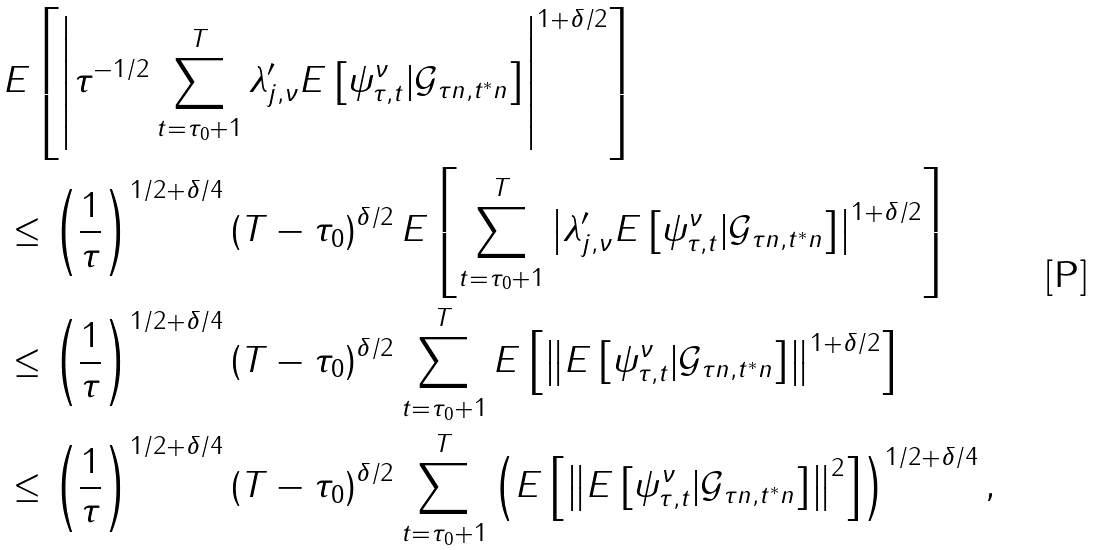<formula> <loc_0><loc_0><loc_500><loc_500>& E \left [ \left | \tau ^ { - 1 / 2 } \sum _ { t = \tau _ { 0 } + 1 } ^ { T } \lambda _ { j , \nu } ^ { \prime } E \left [ \psi _ { \tau , t } ^ { \nu } | \mathcal { G } _ { \tau n , t ^ { \ast } n } \right ] \right | ^ { 1 + \delta / 2 } \right ] \\ & \leq \left ( \frac { 1 } { \tau } \right ) ^ { 1 / 2 + \delta / 4 } \left ( T - \tau _ { 0 } \right ) ^ { \delta / 2 } E \left [ \sum _ { t = \tau _ { 0 } + 1 } ^ { T } \left | \lambda _ { j , \nu } ^ { \prime } E \left [ \psi _ { \tau , t } ^ { \nu } | \mathcal { G } _ { \tau n , t ^ { \ast } n } \right ] \right | ^ { 1 + \delta / 2 } \right ] \\ & \leq \left ( \frac { 1 } { \tau } \right ) ^ { 1 / 2 + \delta / 4 } \left ( T - \tau _ { 0 } \right ) ^ { \delta / 2 } \sum _ { t = \tau _ { 0 } + 1 } ^ { T } E \left [ \left \| E \left [ \psi _ { \tau , t } ^ { \nu } | \mathcal { G } _ { \tau n , t ^ { \ast } n } \right ] \right \| ^ { 1 + \delta / 2 } \right ] \\ & \leq \left ( \frac { 1 } { \tau } \right ) ^ { 1 / 2 + \delta / 4 } \left ( T - \tau _ { 0 } \right ) ^ { \delta / 2 } \sum _ { t = \tau _ { 0 } + 1 } ^ { T } \left ( E \left [ \left \| E \left [ \psi _ { \tau , t } ^ { \nu } | \mathcal { G } _ { \tau n , t ^ { \ast } n } \right ] \right \| ^ { 2 } \right ] \right ) ^ { 1 / 2 + \delta / 4 } ,</formula> 